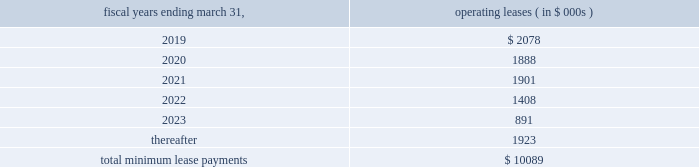Note 11 .
Commitments and contingencies commitments leases the company fffds corporate headquarters is located in danvers , massachusetts .
This facility encompasses most of the company fffds u.s .
Operations , including research and development , manufacturing , sales and marketing and general and administrative departments .
In october 2017 , the acquired its corporate headquarters for approximately $ 16.5 million and terminated its existing lease arrangement ( see note 6 ) .
Future minimum lease payments under non-cancelable leases as of march 31 , 2018 are approximately as follows : fiscal years ending march 31 , operating leases ( in $ 000s ) .
In february 2017 , the company entered into a lease agreement for an additional 21603 square feet of office space in danvers , massachusetts which expires on july 31 , 2022 .
In december 2017 , the company entered into an amendment to this lease to extend the term through august 31 , 2025 and to add an additional 6607 square feet of space in which rent would begin around june 1 , 2018 .
The amendment also allows the company a right of first offer to purchase the property from january 1 , 2018 through august 31 , 2035 , if the lessor decides to sell the building or receives an offer to purchase the building from a third-party buyer .
In march 2018 , the company entered into an amendment to the lease to add an additional 11269 square feet of space for which rent will begin on or around june 1 , 2018 through august 31 , 2025 .
The annual rent expense for this lease agreement is estimated to be $ 0.4 million .
In september 2016 , the company entered into a lease agreement in berlin , germany which commenced in may 2017 and expires in may 2024 .
The annual rent expense for the lease is estimated to be $ 0.3 million .
In october 2016 , the company entered into a lease agreement for an office in tokyokk japan and expires in september 2021 .
The office houses administrative , regulatory , and training personnel in connection with the company fffds commercial launch in japan .
The annual rent expense for the lease is estimated to be $ 0.9 million .
License agreements in april 2014 , the company entered into an exclusive license agreement for the rights to certain optical sensor technologies in the field of cardio-circulatory assist devices .
Pursuant to the terms of the license agreement , the company agreed to make potential payments of $ 6.0 million .
Through march 31 , 2018 , the company has made $ 3.5 million in milestones payments which included a $ 1.5 million upfront payment upon the execution of the agreement .
Any potential future milestone payment amounts have not been included in the contractual obligations table above due to the uncertainty related to the successful achievement of these milestones .
Contingencies from time to time , the company is involved in legal and administrative proceedings and claims of various types .
In some actions , the claimants seek damages , as well as other relief , which , if granted , would require significant expenditures .
The company records a liability in its consolidated financial statements for these matters when a loss is known or considered probable and the amount can be reasonably estimated .
The company reviews these estimates each accounting period as additional information is known and adjusts the loss provision when appropriate .
If a matter is both probable to result in liability and the amount of loss can be reasonably estimated , the company estimates and discloses the possible loss or range of loss .
If the loss is not probable or cannot be reasonably estimated , a liability is not recorded in its consolidated financial statements. .
What percent of non-cancelable future minimum lease payments are due after 5 years?\\n\\n? 
Computations: (1923 / 10089)
Answer: 0.1906. Note 11 .
Commitments and contingencies commitments leases the company fffds corporate headquarters is located in danvers , massachusetts .
This facility encompasses most of the company fffds u.s .
Operations , including research and development , manufacturing , sales and marketing and general and administrative departments .
In october 2017 , the acquired its corporate headquarters for approximately $ 16.5 million and terminated its existing lease arrangement ( see note 6 ) .
Future minimum lease payments under non-cancelable leases as of march 31 , 2018 are approximately as follows : fiscal years ending march 31 , operating leases ( in $ 000s ) .
In february 2017 , the company entered into a lease agreement for an additional 21603 square feet of office space in danvers , massachusetts which expires on july 31 , 2022 .
In december 2017 , the company entered into an amendment to this lease to extend the term through august 31 , 2025 and to add an additional 6607 square feet of space in which rent would begin around june 1 , 2018 .
The amendment also allows the company a right of first offer to purchase the property from january 1 , 2018 through august 31 , 2035 , if the lessor decides to sell the building or receives an offer to purchase the building from a third-party buyer .
In march 2018 , the company entered into an amendment to the lease to add an additional 11269 square feet of space for which rent will begin on or around june 1 , 2018 through august 31 , 2025 .
The annual rent expense for this lease agreement is estimated to be $ 0.4 million .
In september 2016 , the company entered into a lease agreement in berlin , germany which commenced in may 2017 and expires in may 2024 .
The annual rent expense for the lease is estimated to be $ 0.3 million .
In october 2016 , the company entered into a lease agreement for an office in tokyokk japan and expires in september 2021 .
The office houses administrative , regulatory , and training personnel in connection with the company fffds commercial launch in japan .
The annual rent expense for the lease is estimated to be $ 0.9 million .
License agreements in april 2014 , the company entered into an exclusive license agreement for the rights to certain optical sensor technologies in the field of cardio-circulatory assist devices .
Pursuant to the terms of the license agreement , the company agreed to make potential payments of $ 6.0 million .
Through march 31 , 2018 , the company has made $ 3.5 million in milestones payments which included a $ 1.5 million upfront payment upon the execution of the agreement .
Any potential future milestone payment amounts have not been included in the contractual obligations table above due to the uncertainty related to the successful achievement of these milestones .
Contingencies from time to time , the company is involved in legal and administrative proceedings and claims of various types .
In some actions , the claimants seek damages , as well as other relief , which , if granted , would require significant expenditures .
The company records a liability in its consolidated financial statements for these matters when a loss is known or considered probable and the amount can be reasonably estimated .
The company reviews these estimates each accounting period as additional information is known and adjusts the loss provision when appropriate .
If a matter is both probable to result in liability and the amount of loss can be reasonably estimated , the company estimates and discloses the possible loss or range of loss .
If the loss is not probable or cannot be reasonably estimated , a liability is not recorded in its consolidated financial statements. .
What is the expected growth rate in operating leases from 2020 to 2021? 
Computations: ((1901 - 1888) / 1888)
Answer: 0.00689. 